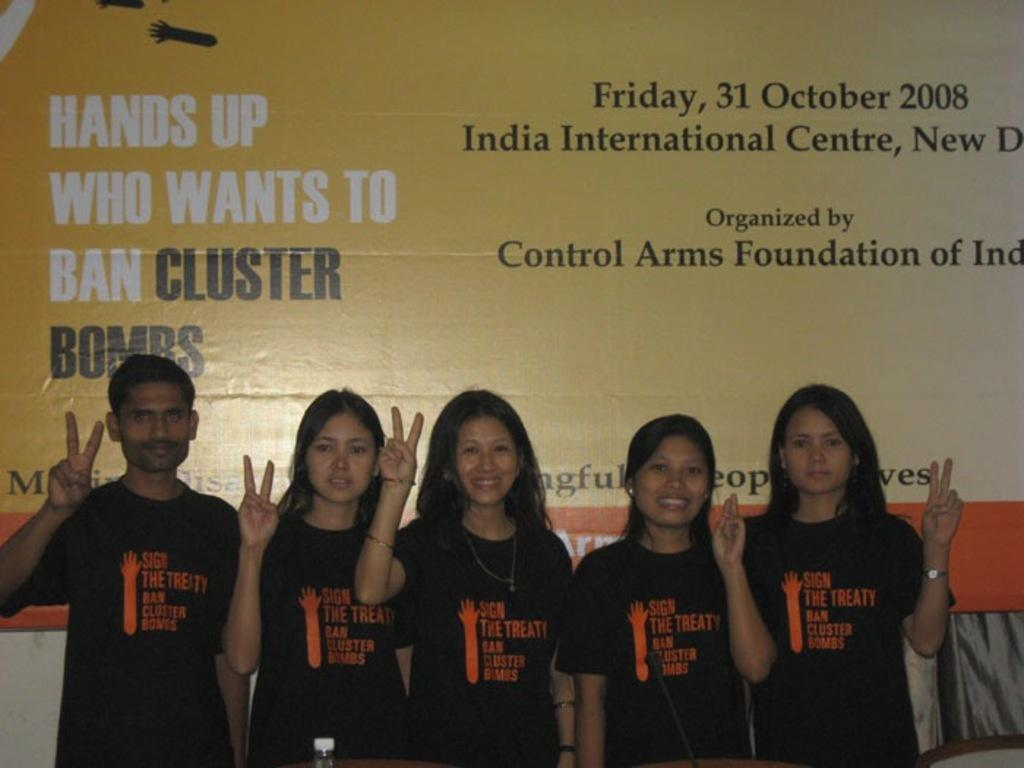How many people are present in the image? There are five persons in the image. Can you describe any details about the clothing of the people in the image? There is text on the shirt of at least one person. What can be seen in the background of the image? There is a wall and a banner with text visible in the background of the image. Are any of the persons wearing masks in the image? There is no mention of masks in the image, so we cannot determine if any of the persons are wearing them. What type of waste is being disposed of in the image? There is no waste present in the image; it features five persons and a background with a wall and a banner. 